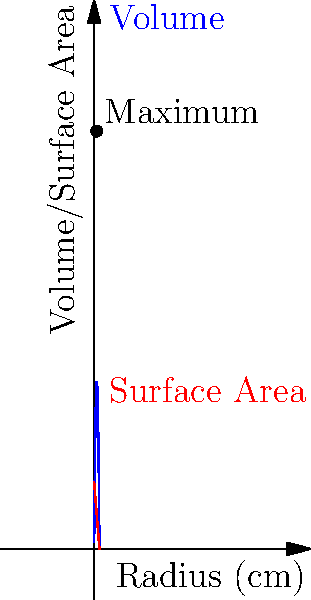A trekking enthusiast in Bangalore wants to design a cylindrical water bottle with a volume of 1000 cm³. If the material cost is proportional to the surface area, what dimensions (radius and height) will minimize the cost while maintaining the required volume? Let's approach this step-by-step:

1) Let $r$ be the radius and $h$ be the height of the cylinder.

2) The volume of a cylinder is given by $V = \pi r^2 h$. We're told that $V = 1000$ cm³.

3) The surface area of a cylinder (including top and bottom) is $S = 2\pi r^2 + 2\pi rh$.

4) From the volume equation, we can express $h$ in terms of $r$:
   $h = \frac{1000}{\pi r^2}$

5) Substituting this into the surface area equation:
   $S = 2\pi r^2 + 2\pi r(\frac{1000}{\pi r^2}) = 2\pi r^2 + \frac{2000}{r}$

6) To minimize $S$, we differentiate with respect to $r$ and set it to zero:
   $\frac{dS}{dr} = 4\pi r - \frac{2000}{r^2} = 0$

7) Solving this equation:
   $4\pi r^3 = 2000$
   $r^3 = \frac{500}{\pi}$
   $r = \sqrt[3]{\frac{500}{\pi}} \approx 5$ cm

8) We can now find $h$:
   $h = \frac{1000}{\pi r^2} = \frac{1000}{\pi(5^2)} \approx 12.7$ cm

9) To verify, we can calculate the volume:
   $V = \pi r^2 h = \pi(5^2)(12.7) \approx 1000$ cm³

The graph shows the volume and surface area as functions of the radius. The maximum point on the volume curve corresponds to the optimal dimensions.
Answer: Radius ≈ 5 cm, Height ≈ 12.7 cm 